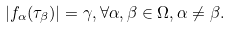Convert formula to latex. <formula><loc_0><loc_0><loc_500><loc_500>| f _ { \alpha } ( \tau _ { \beta } ) | = \gamma , \forall \alpha , \beta \in \Omega , \alpha \neq \beta .</formula> 